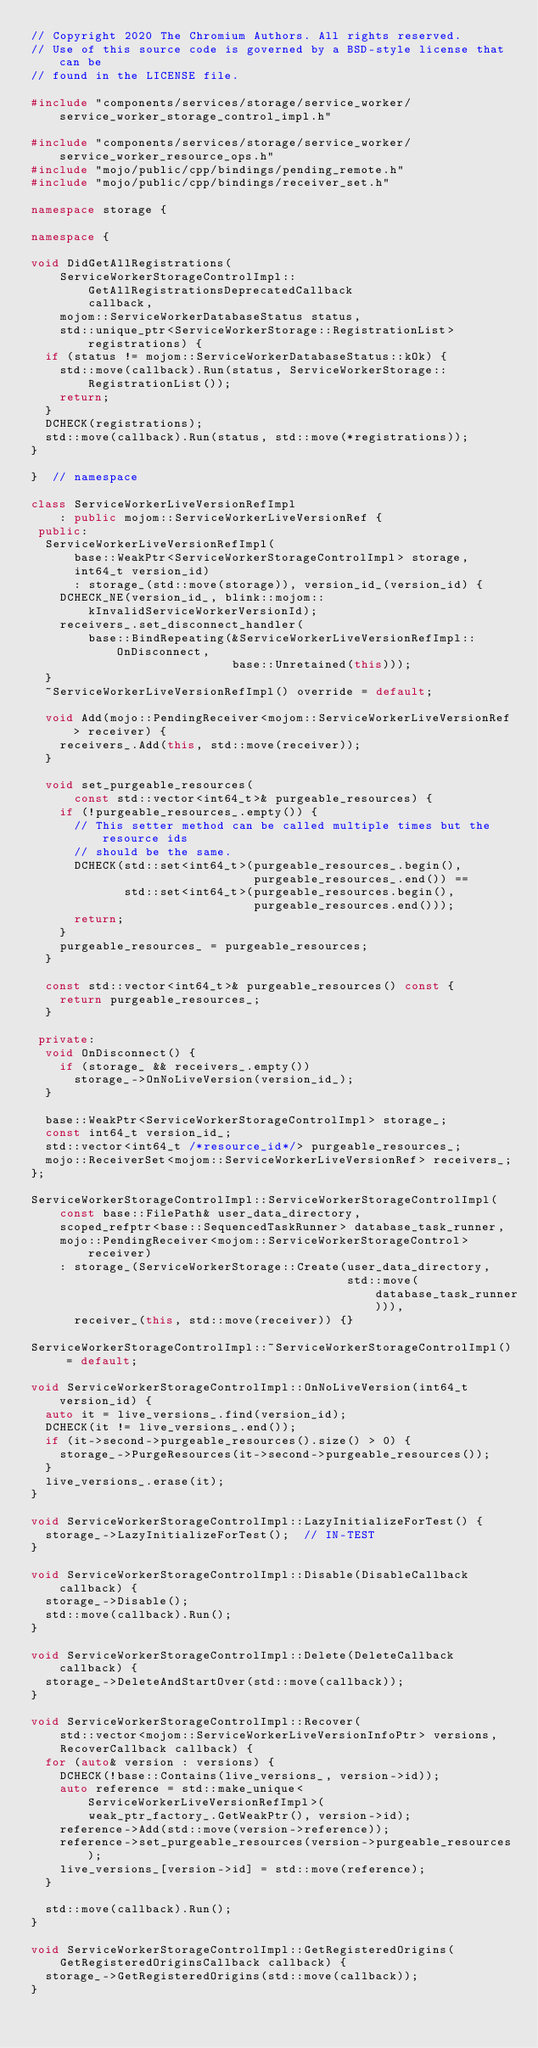Convert code to text. <code><loc_0><loc_0><loc_500><loc_500><_C++_>// Copyright 2020 The Chromium Authors. All rights reserved.
// Use of this source code is governed by a BSD-style license that can be
// found in the LICENSE file.

#include "components/services/storage/service_worker/service_worker_storage_control_impl.h"

#include "components/services/storage/service_worker/service_worker_resource_ops.h"
#include "mojo/public/cpp/bindings/pending_remote.h"
#include "mojo/public/cpp/bindings/receiver_set.h"

namespace storage {

namespace {

void DidGetAllRegistrations(
    ServiceWorkerStorageControlImpl::GetAllRegistrationsDeprecatedCallback
        callback,
    mojom::ServiceWorkerDatabaseStatus status,
    std::unique_ptr<ServiceWorkerStorage::RegistrationList> registrations) {
  if (status != mojom::ServiceWorkerDatabaseStatus::kOk) {
    std::move(callback).Run(status, ServiceWorkerStorage::RegistrationList());
    return;
  }
  DCHECK(registrations);
  std::move(callback).Run(status, std::move(*registrations));
}

}  // namespace

class ServiceWorkerLiveVersionRefImpl
    : public mojom::ServiceWorkerLiveVersionRef {
 public:
  ServiceWorkerLiveVersionRefImpl(
      base::WeakPtr<ServiceWorkerStorageControlImpl> storage,
      int64_t version_id)
      : storage_(std::move(storage)), version_id_(version_id) {
    DCHECK_NE(version_id_, blink::mojom::kInvalidServiceWorkerVersionId);
    receivers_.set_disconnect_handler(
        base::BindRepeating(&ServiceWorkerLiveVersionRefImpl::OnDisconnect,
                            base::Unretained(this)));
  }
  ~ServiceWorkerLiveVersionRefImpl() override = default;

  void Add(mojo::PendingReceiver<mojom::ServiceWorkerLiveVersionRef> receiver) {
    receivers_.Add(this, std::move(receiver));
  }

  void set_purgeable_resources(
      const std::vector<int64_t>& purgeable_resources) {
    if (!purgeable_resources_.empty()) {
      // This setter method can be called multiple times but the resource ids
      // should be the same.
      DCHECK(std::set<int64_t>(purgeable_resources_.begin(),
                               purgeable_resources_.end()) ==
             std::set<int64_t>(purgeable_resources.begin(),
                               purgeable_resources.end()));
      return;
    }
    purgeable_resources_ = purgeable_resources;
  }

  const std::vector<int64_t>& purgeable_resources() const {
    return purgeable_resources_;
  }

 private:
  void OnDisconnect() {
    if (storage_ && receivers_.empty())
      storage_->OnNoLiveVersion(version_id_);
  }

  base::WeakPtr<ServiceWorkerStorageControlImpl> storage_;
  const int64_t version_id_;
  std::vector<int64_t /*resource_id*/> purgeable_resources_;
  mojo::ReceiverSet<mojom::ServiceWorkerLiveVersionRef> receivers_;
};

ServiceWorkerStorageControlImpl::ServiceWorkerStorageControlImpl(
    const base::FilePath& user_data_directory,
    scoped_refptr<base::SequencedTaskRunner> database_task_runner,
    mojo::PendingReceiver<mojom::ServiceWorkerStorageControl> receiver)
    : storage_(ServiceWorkerStorage::Create(user_data_directory,
                                            std::move(database_task_runner))),
      receiver_(this, std::move(receiver)) {}

ServiceWorkerStorageControlImpl::~ServiceWorkerStorageControlImpl() = default;

void ServiceWorkerStorageControlImpl::OnNoLiveVersion(int64_t version_id) {
  auto it = live_versions_.find(version_id);
  DCHECK(it != live_versions_.end());
  if (it->second->purgeable_resources().size() > 0) {
    storage_->PurgeResources(it->second->purgeable_resources());
  }
  live_versions_.erase(it);
}

void ServiceWorkerStorageControlImpl::LazyInitializeForTest() {
  storage_->LazyInitializeForTest();  // IN-TEST
}

void ServiceWorkerStorageControlImpl::Disable(DisableCallback callback) {
  storage_->Disable();
  std::move(callback).Run();
}

void ServiceWorkerStorageControlImpl::Delete(DeleteCallback callback) {
  storage_->DeleteAndStartOver(std::move(callback));
}

void ServiceWorkerStorageControlImpl::Recover(
    std::vector<mojom::ServiceWorkerLiveVersionInfoPtr> versions,
    RecoverCallback callback) {
  for (auto& version : versions) {
    DCHECK(!base::Contains(live_versions_, version->id));
    auto reference = std::make_unique<ServiceWorkerLiveVersionRefImpl>(
        weak_ptr_factory_.GetWeakPtr(), version->id);
    reference->Add(std::move(version->reference));
    reference->set_purgeable_resources(version->purgeable_resources);
    live_versions_[version->id] = std::move(reference);
  }

  std::move(callback).Run();
}

void ServiceWorkerStorageControlImpl::GetRegisteredOrigins(
    GetRegisteredOriginsCallback callback) {
  storage_->GetRegisteredOrigins(std::move(callback));
}
</code> 